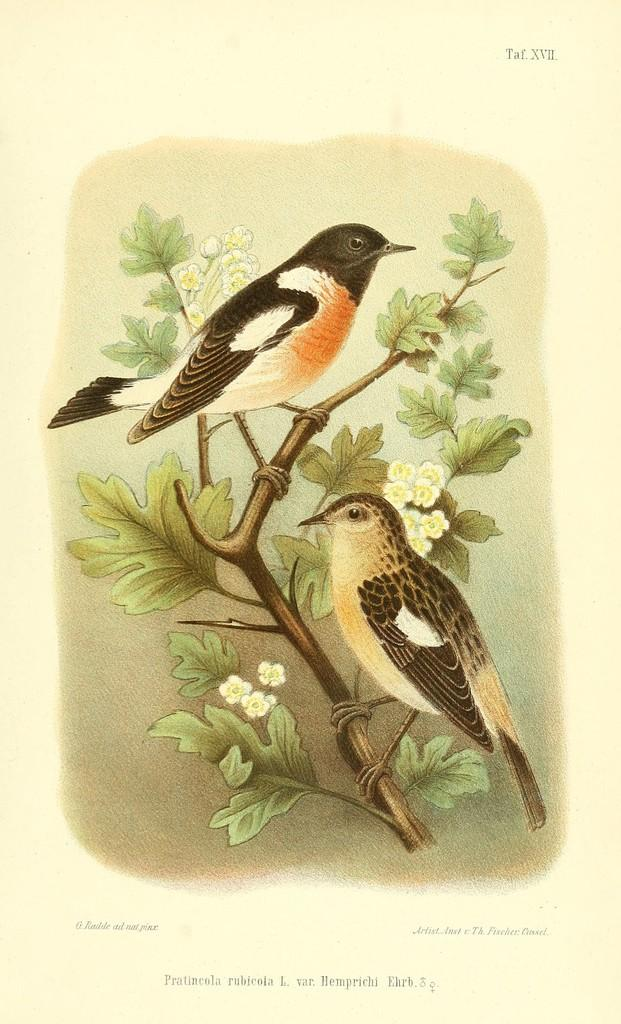What is depicted on the paper in the image? The paper has a photo of two birds. What are the birds doing in the photo? The birds are standing on a tree in the photo. Are there any words or symbols on the paper? Yes, there are words and roman numerals on the paper. How does the family react to the fight in the image? There is no family or fight present in the image; it features a paper with a photo of two birds. 